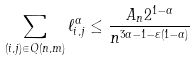<formula> <loc_0><loc_0><loc_500><loc_500>\sum _ { ( i , j ) \in Q ( n , m ) } \ell _ { i , j } ^ { \alpha } \leq \frac { A _ { n } 2 ^ { 1 - \alpha } } { n ^ { 3 \alpha - 1 - \varepsilon ( 1 - \alpha ) } }</formula> 